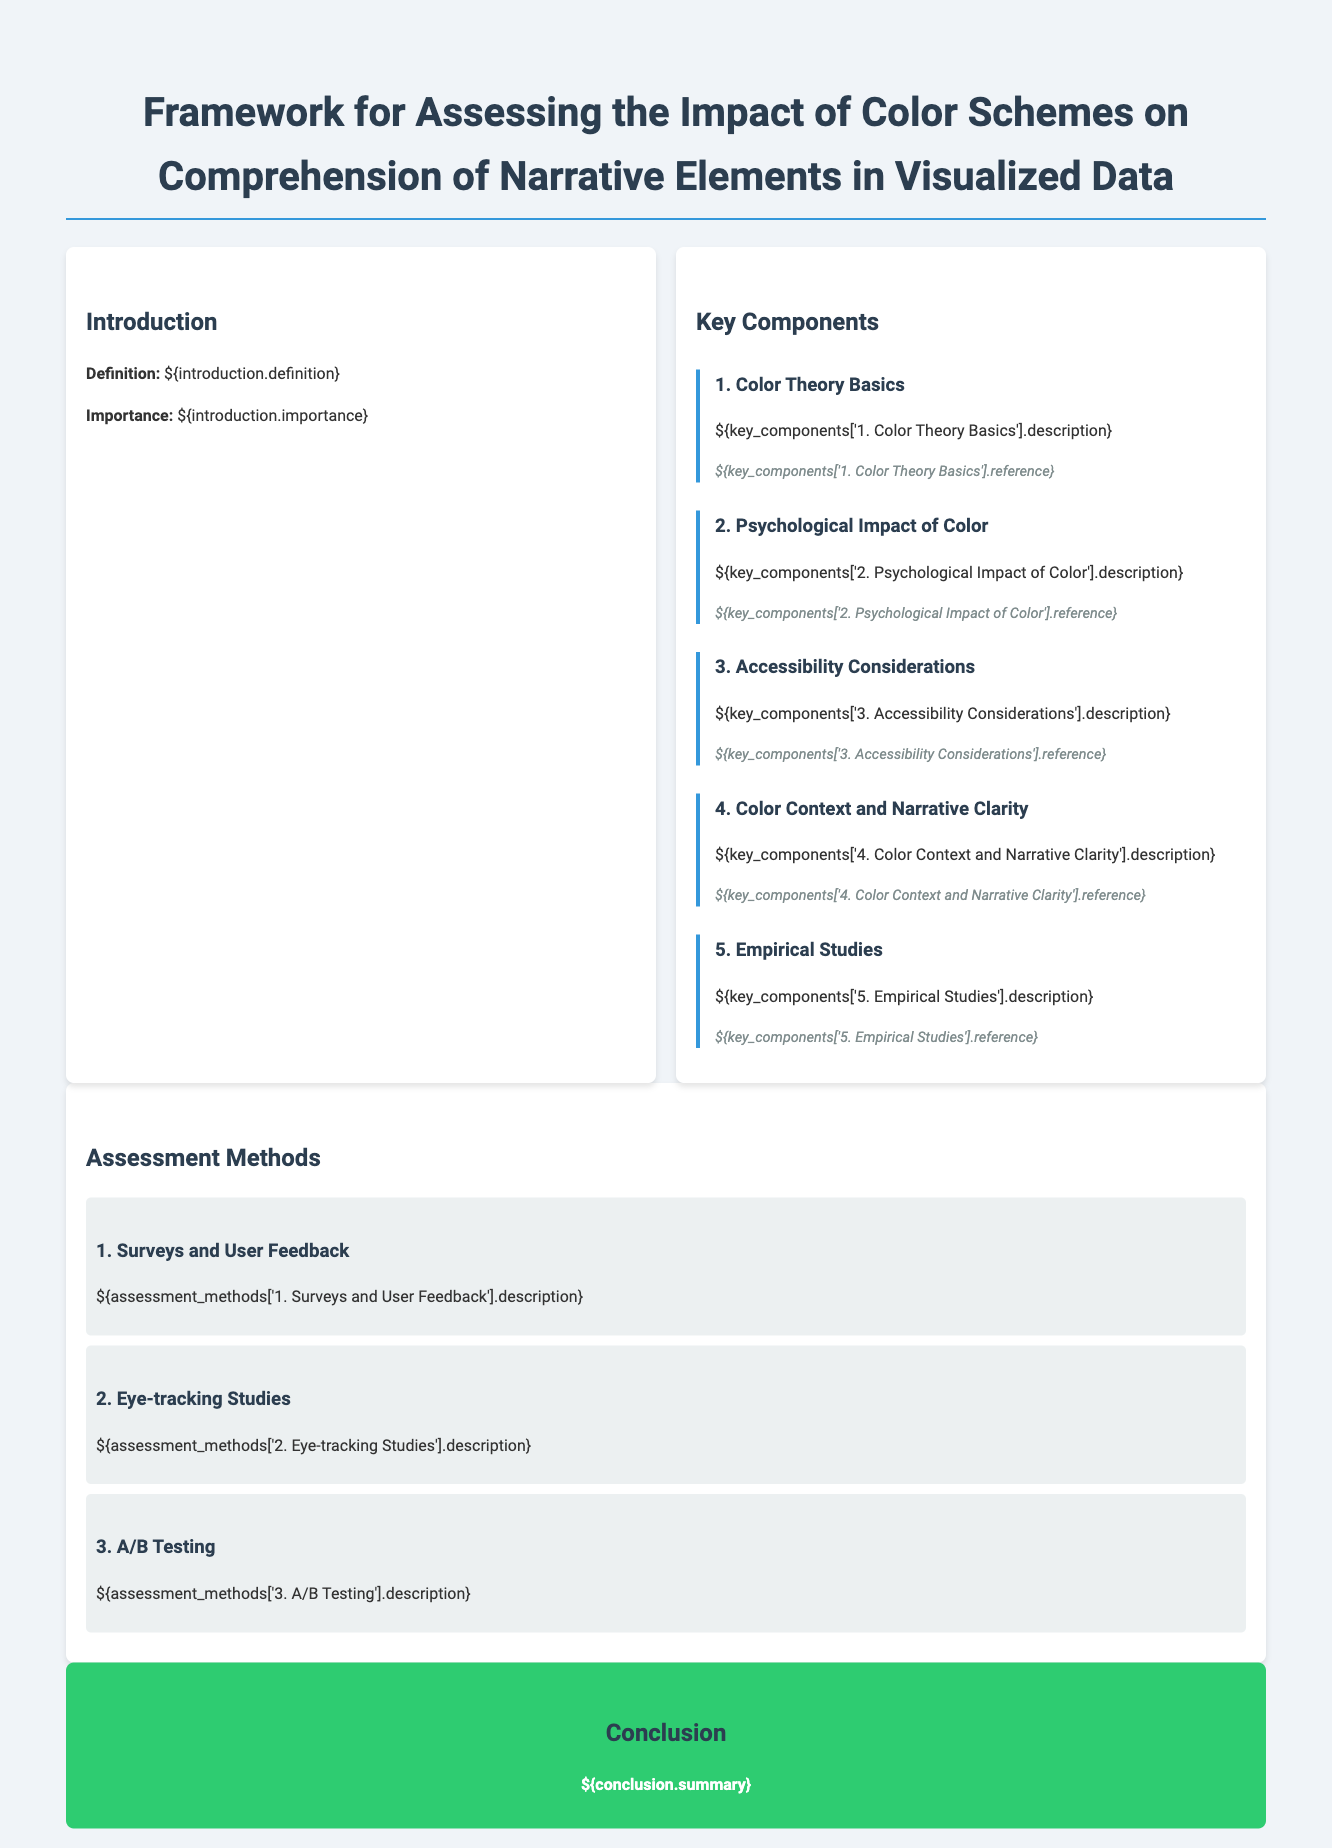What is the title of the document? The title is indicated at the top of the document within the `<h1>` tag.
Answer: Framework for Assessing the Impact of Color Schemes on Comprehension of Narrative Elements in Visualized Data How many key components are listed? The number of key components is organized under the "Key Components" section.
Answer: 5 Which method involves user feedback? The method is mentioned in the "Assessment Methods" section under a clear heading.
Answer: Surveys and User Feedback What color is used for headings? The document specifies the color style applied to headings in the CSS section.
Answer: #2c3e50 What is the primary purpose of the framework? The purpose is described in the "Introduction" section and centers on the definition.
Answer: Assessing the impact of color schemes on comprehension What psychological effect does color have according to the document? This effect can be inferred from the description under the key component dedicated to psychological impact.
Answer: Influence on understanding What is the background color of the section container? The background color can be identified in the style defined in the CSS for the section elements.
Answer: White What is the conclusion's background color? The conclusion’s styling is indicated in the CSS where the color is specified.
Answer: #2ecc71 What research method uses eye-tracking technology? The method utilizing this technology is explicitly mentioned in the "Assessment Methods" section.
Answer: Eye-tracking Studies 